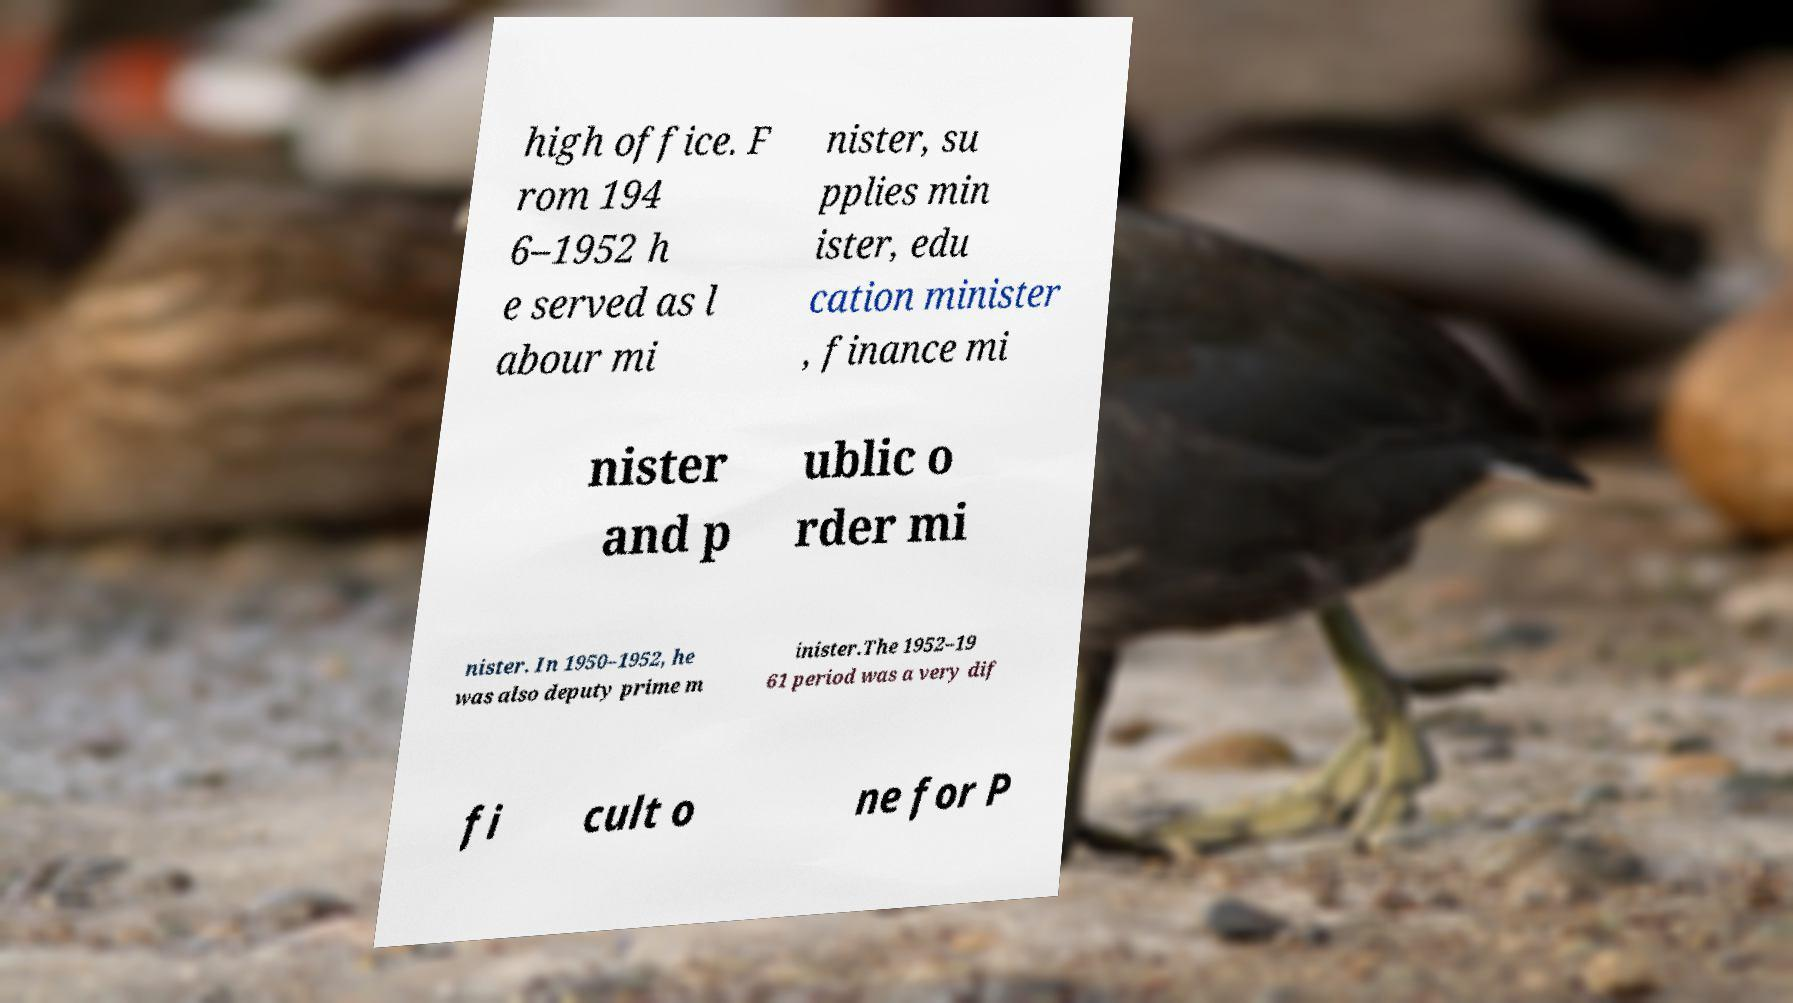Can you read and provide the text displayed in the image?This photo seems to have some interesting text. Can you extract and type it out for me? high office. F rom 194 6–1952 h e served as l abour mi nister, su pplies min ister, edu cation minister , finance mi nister and p ublic o rder mi nister. In 1950–1952, he was also deputy prime m inister.The 1952–19 61 period was a very dif fi cult o ne for P 